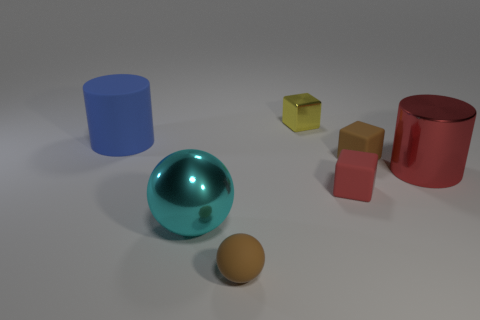Is the number of large objects to the right of the metallic sphere greater than the number of blue matte objects that are in front of the blue matte object?
Provide a succinct answer. Yes. What is the shape of the large metal object on the left side of the sphere in front of the large shiny thing that is on the left side of the red matte block?
Ensure brevity in your answer.  Sphere. What shape is the big thing in front of the cylinder that is in front of the big matte cylinder?
Give a very brief answer. Sphere. Is there a cylinder that has the same material as the brown block?
Make the answer very short. Yes. How many cyan objects are metallic things or small rubber blocks?
Ensure brevity in your answer.  1. Are there any tiny cubes that have the same color as the large metal cylinder?
Your response must be concise. Yes. What is the size of the blue object that is made of the same material as the tiny red thing?
Offer a terse response. Large. What number of cylinders are either big cyan things or blue matte things?
Give a very brief answer. 1. Is the number of large cyan spheres greater than the number of small purple shiny spheres?
Offer a very short reply. Yes. How many red shiny cylinders have the same size as the metallic block?
Your answer should be compact. 0. 